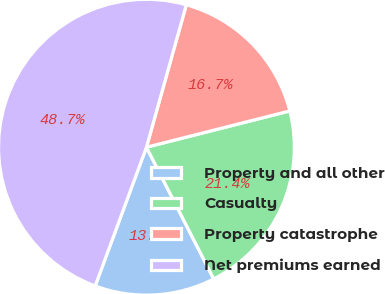Convert chart. <chart><loc_0><loc_0><loc_500><loc_500><pie_chart><fcel>Property and all other<fcel>Casualty<fcel>Property catastrophe<fcel>Net premiums earned<nl><fcel>13.15%<fcel>21.43%<fcel>16.71%<fcel>48.71%<nl></chart> 